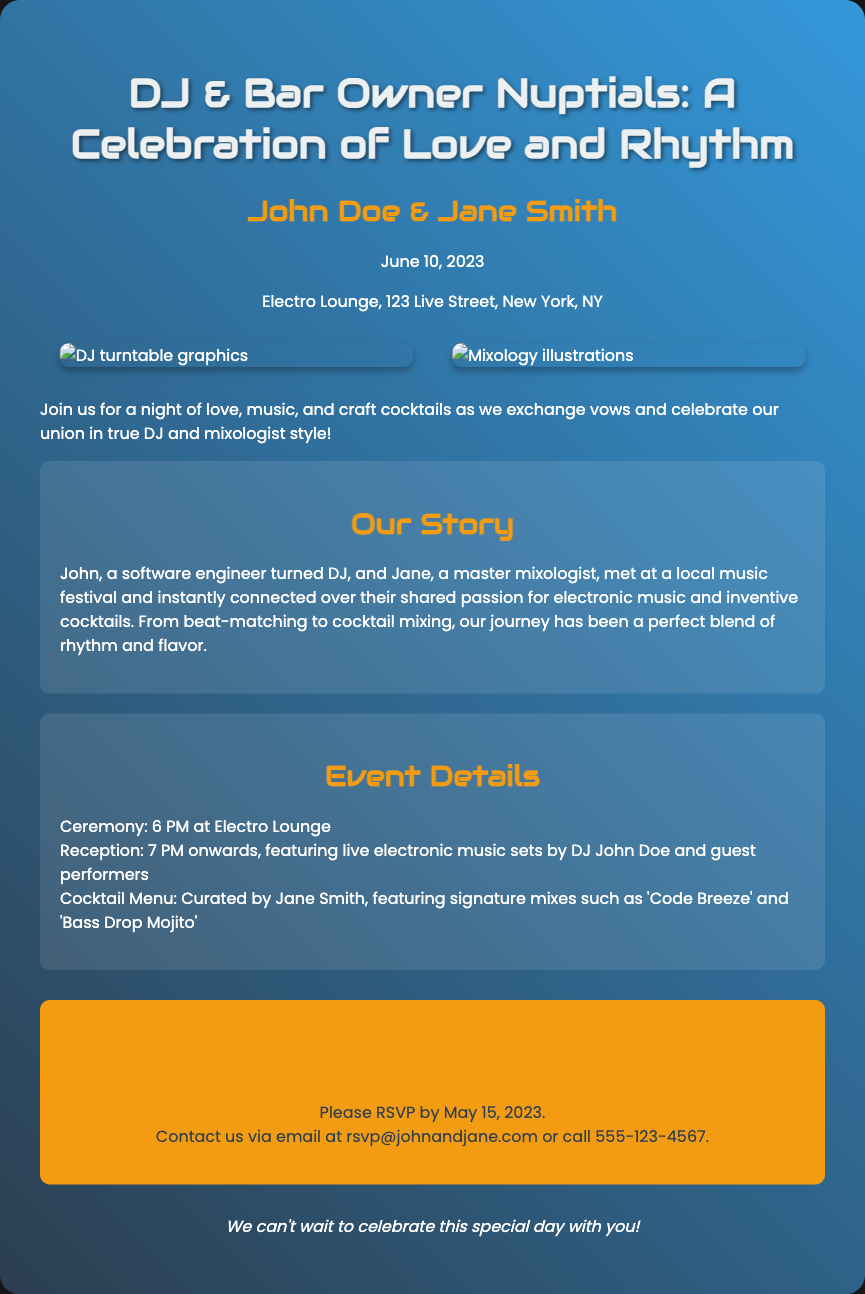What is the date of the wedding? The date of the wedding is explicitly mentioned in the document as June 10, 2023.
Answer: June 10, 2023 Who are the couple getting married? The names of the couple getting married are provided in the document as John Doe and Jane Smith.
Answer: John Doe & Jane Smith Where is the wedding ceremony taking place? The location of the wedding ceremony is specified in the document as Electro Lounge, 123 Live Street, New York, NY.
Answer: Electro Lounge, 123 Live Street, New York, NY What time does the ceremony start? The document clearly states the ceremony starts at 6 PM.
Answer: 6 PM What type of event will take place after the ceremony? The document states that there will be a reception following the ceremony, featuring live electronic music sets.
Answer: Reception with live electronic music What is one of the signature cocktail mixes mentioned? The document lists signature mixes curated by Jane Smith, one of which is 'Code Breeze.'
Answer: 'Code Breeze' Why did John and Jane connect? According to the document, John and Jane connected over their shared passion for electronic music and inventive cocktails.
Answer: Shared passion for electronic music and inventive cocktails What is the RSVP deadline? The document indicates that the RSVP must be sent by May 15, 2023.
Answer: May 15, 2023 How can guests RSVP? The document provides contact details for RSVP, allowing guests to email or call the couple.
Answer: email at rsvp@johnandjane.com or call 555-123-4567 